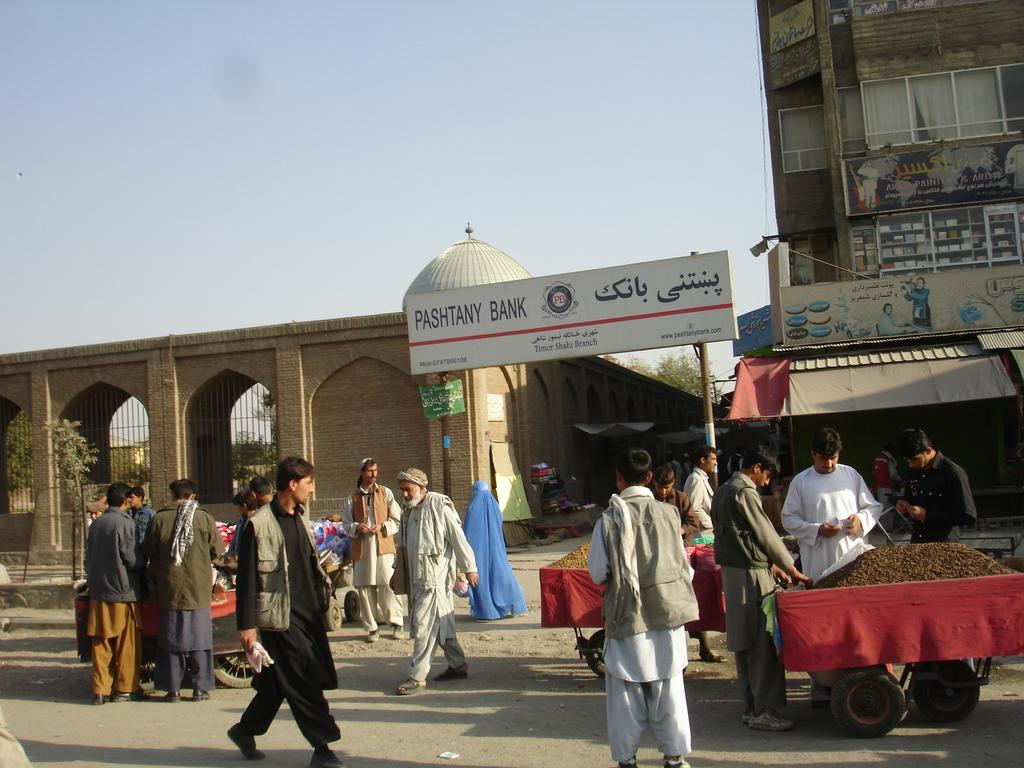What are the people in the image doing? The people in the image are walking on the road. What type of vehicles can be seen in the image? There are carts visible in the image. What can be seen in the distance in the image? There are buildings and boards visible in the background of the image. What type of can is being used to catch fish in the image? There is no can present in the image, and no fishing activity is depicted. 